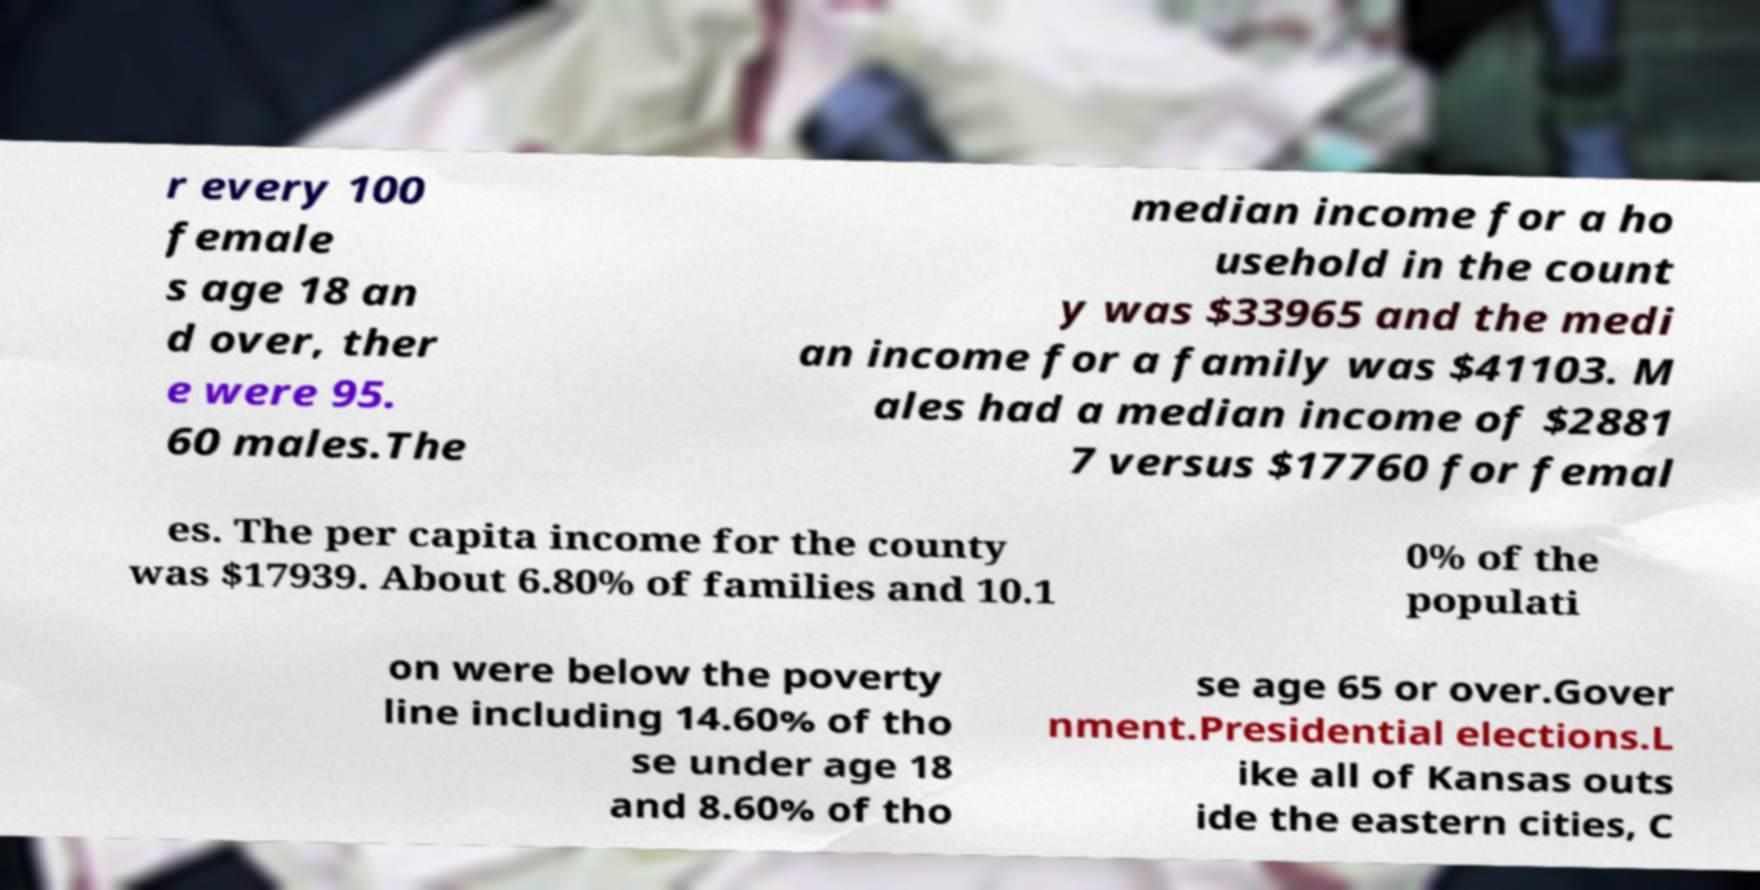Please identify and transcribe the text found in this image. r every 100 female s age 18 an d over, ther e were 95. 60 males.The median income for a ho usehold in the count y was $33965 and the medi an income for a family was $41103. M ales had a median income of $2881 7 versus $17760 for femal es. The per capita income for the county was $17939. About 6.80% of families and 10.1 0% of the populati on were below the poverty line including 14.60% of tho se under age 18 and 8.60% of tho se age 65 or over.Gover nment.Presidential elections.L ike all of Kansas outs ide the eastern cities, C 